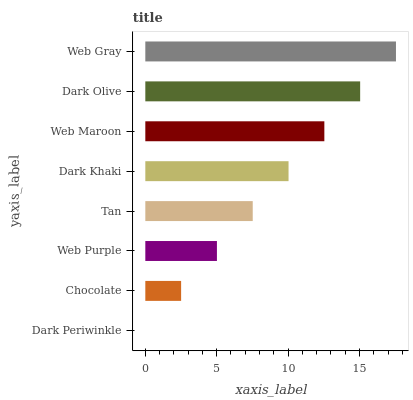Is Dark Periwinkle the minimum?
Answer yes or no. Yes. Is Web Gray the maximum?
Answer yes or no. Yes. Is Chocolate the minimum?
Answer yes or no. No. Is Chocolate the maximum?
Answer yes or no. No. Is Chocolate greater than Dark Periwinkle?
Answer yes or no. Yes. Is Dark Periwinkle less than Chocolate?
Answer yes or no. Yes. Is Dark Periwinkle greater than Chocolate?
Answer yes or no. No. Is Chocolate less than Dark Periwinkle?
Answer yes or no. No. Is Dark Khaki the high median?
Answer yes or no. Yes. Is Tan the low median?
Answer yes or no. Yes. Is Web Gray the high median?
Answer yes or no. No. Is Dark Khaki the low median?
Answer yes or no. No. 